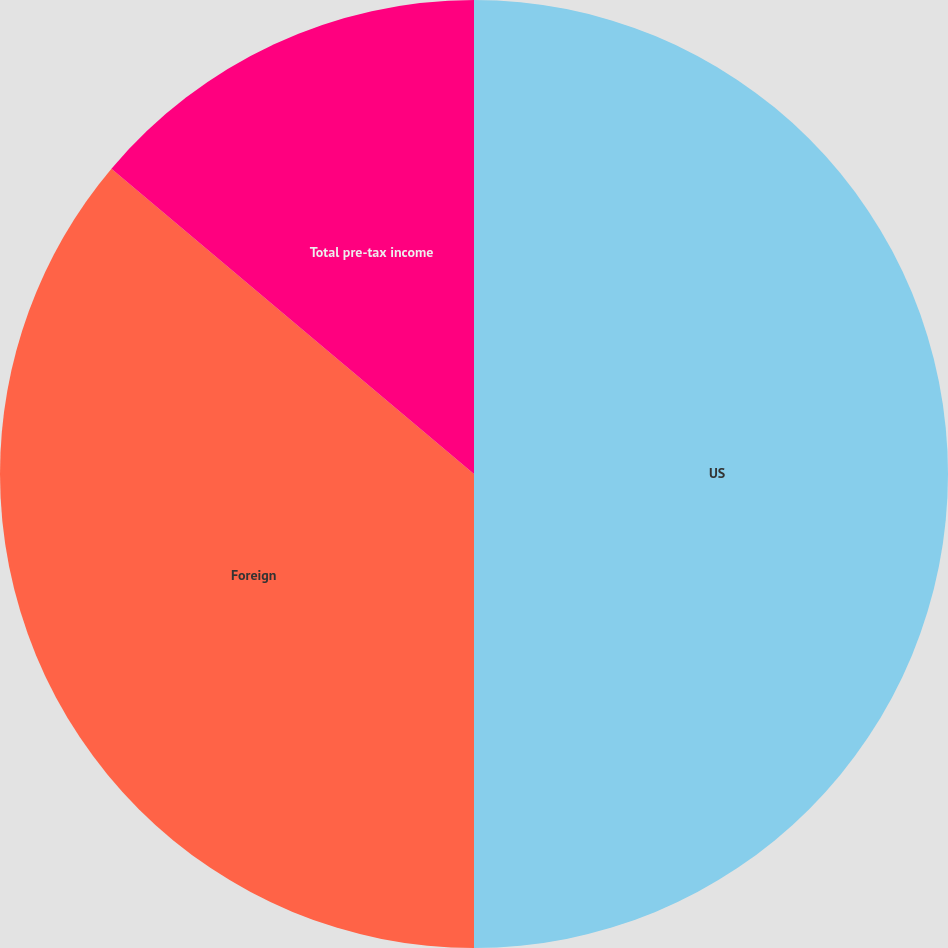Convert chart to OTSL. <chart><loc_0><loc_0><loc_500><loc_500><pie_chart><fcel>US<fcel>Foreign<fcel>Total pre-tax income<nl><fcel>50.0%<fcel>36.14%<fcel>13.86%<nl></chart> 